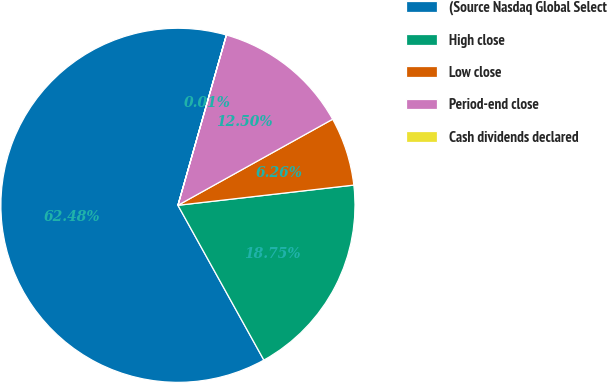Convert chart to OTSL. <chart><loc_0><loc_0><loc_500><loc_500><pie_chart><fcel>(Source Nasdaq Global Select<fcel>High close<fcel>Low close<fcel>Period-end close<fcel>Cash dividends declared<nl><fcel>62.47%<fcel>18.75%<fcel>6.26%<fcel>12.5%<fcel>0.01%<nl></chart> 